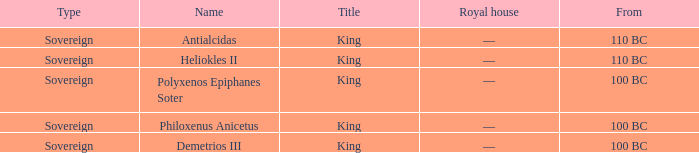When did Philoxenus Anicetus begin to hold power? 100 BC. 